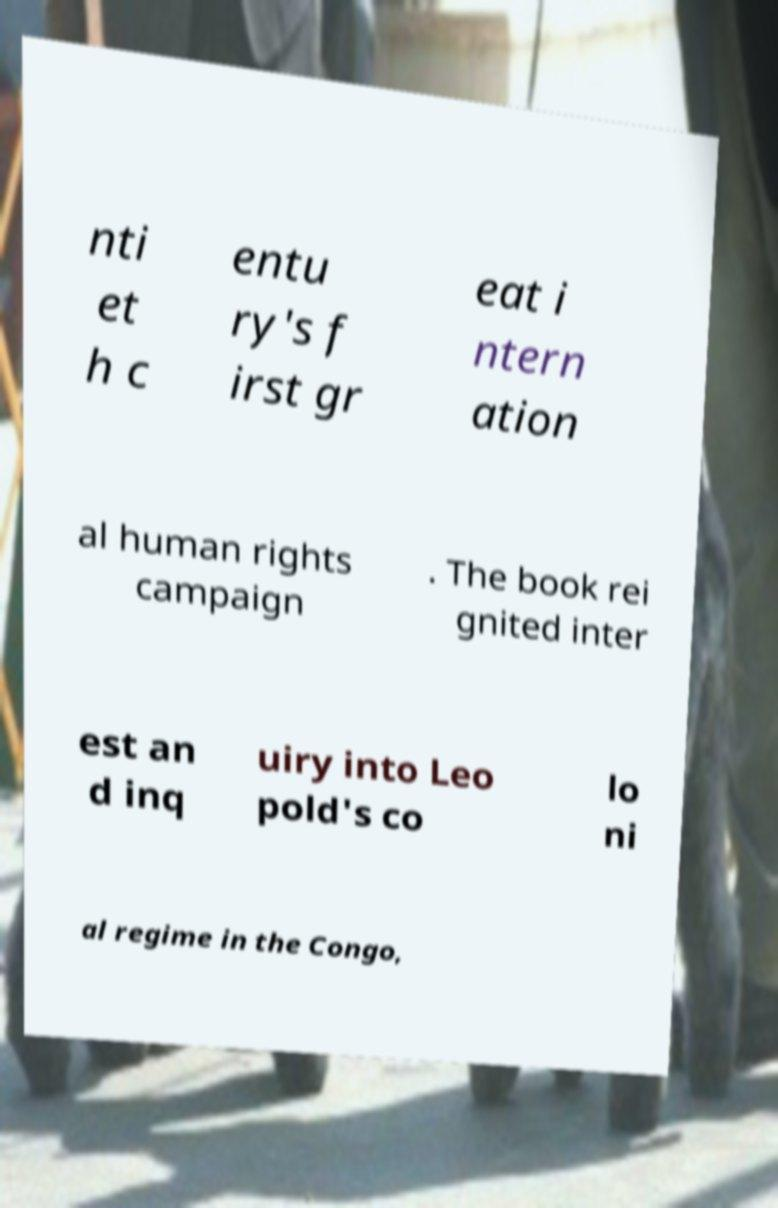For documentation purposes, I need the text within this image transcribed. Could you provide that? nti et h c entu ry's f irst gr eat i ntern ation al human rights campaign . The book rei gnited inter est an d inq uiry into Leo pold's co lo ni al regime in the Congo, 